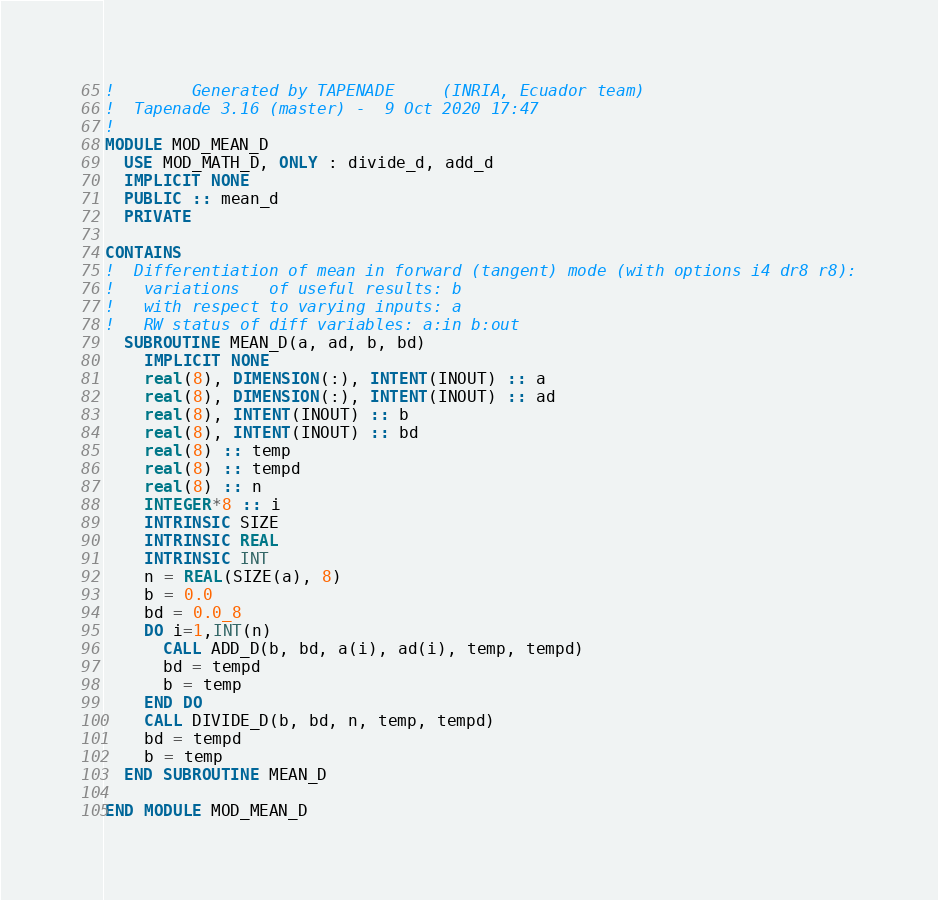<code> <loc_0><loc_0><loc_500><loc_500><_FORTRAN_>!        Generated by TAPENADE     (INRIA, Ecuador team)
!  Tapenade 3.16 (master) -  9 Oct 2020 17:47
!
MODULE MOD_MEAN_D
  USE MOD_MATH_D, ONLY : divide_d, add_d
  IMPLICIT NONE
  PUBLIC :: mean_d
  PRIVATE 

CONTAINS
!  Differentiation of mean in forward (tangent) mode (with options i4 dr8 r8):
!   variations   of useful results: b
!   with respect to varying inputs: a
!   RW status of diff variables: a:in b:out
  SUBROUTINE MEAN_D(a, ad, b, bd)
    IMPLICIT NONE
    real(8), DIMENSION(:), INTENT(INOUT) :: a
    real(8), DIMENSION(:), INTENT(INOUT) :: ad
    real(8), INTENT(INOUT) :: b
    real(8), INTENT(INOUT) :: bd
    real(8) :: temp
    real(8) :: tempd
    real(8) :: n
    INTEGER*8 :: i
    INTRINSIC SIZE
    INTRINSIC REAL
    INTRINSIC INT
    n = REAL(SIZE(a), 8)
    b = 0.0
    bd = 0.0_8
    DO i=1,INT(n)
      CALL ADD_D(b, bd, a(i), ad(i), temp, tempd)
      bd = tempd
      b = temp
    END DO
    CALL DIVIDE_D(b, bd, n, temp, tempd)
    bd = tempd
    b = temp
  END SUBROUTINE MEAN_D

END MODULE MOD_MEAN_D
</code> 